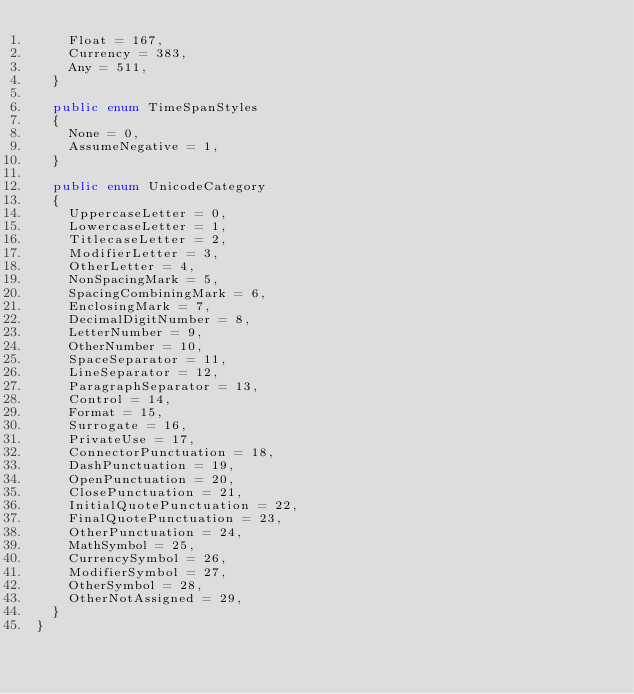<code> <loc_0><loc_0><loc_500><loc_500><_C#_>    Float = 167, 
    Currency = 383, 
    Any = 511, 
  }

  public enum TimeSpanStyles
  {
    None = 0, 
    AssumeNegative = 1, 
  }

  public enum UnicodeCategory
  {
    UppercaseLetter = 0, 
    LowercaseLetter = 1, 
    TitlecaseLetter = 2, 
    ModifierLetter = 3, 
    OtherLetter = 4, 
    NonSpacingMark = 5, 
    SpacingCombiningMark = 6, 
    EnclosingMark = 7, 
    DecimalDigitNumber = 8, 
    LetterNumber = 9, 
    OtherNumber = 10, 
    SpaceSeparator = 11, 
    LineSeparator = 12, 
    ParagraphSeparator = 13, 
    Control = 14, 
    Format = 15, 
    Surrogate = 16, 
    PrivateUse = 17, 
    ConnectorPunctuation = 18, 
    DashPunctuation = 19, 
    OpenPunctuation = 20, 
    ClosePunctuation = 21, 
    InitialQuotePunctuation = 22, 
    FinalQuotePunctuation = 23, 
    OtherPunctuation = 24, 
    MathSymbol = 25, 
    CurrencySymbol = 26, 
    ModifierSymbol = 27, 
    OtherSymbol = 28, 
    OtherNotAssigned = 29, 
  }
}
</code> 